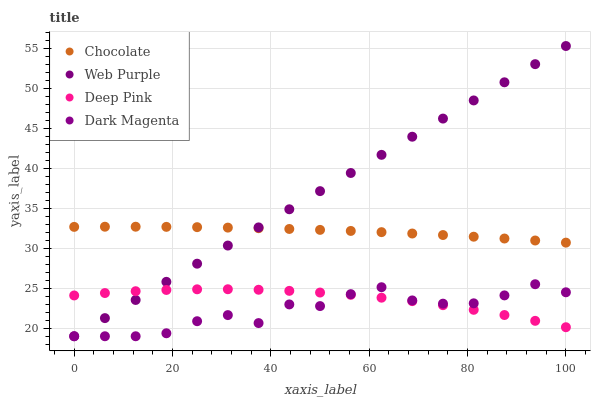Does Dark Magenta have the minimum area under the curve?
Answer yes or no. Yes. Does Web Purple have the maximum area under the curve?
Answer yes or no. Yes. Does Deep Pink have the minimum area under the curve?
Answer yes or no. No. Does Deep Pink have the maximum area under the curve?
Answer yes or no. No. Is Web Purple the smoothest?
Answer yes or no. Yes. Is Dark Magenta the roughest?
Answer yes or no. Yes. Is Deep Pink the smoothest?
Answer yes or no. No. Is Deep Pink the roughest?
Answer yes or no. No. Does Web Purple have the lowest value?
Answer yes or no. Yes. Does Deep Pink have the lowest value?
Answer yes or no. No. Does Web Purple have the highest value?
Answer yes or no. Yes. Does Dark Magenta have the highest value?
Answer yes or no. No. Is Deep Pink less than Chocolate?
Answer yes or no. Yes. Is Chocolate greater than Deep Pink?
Answer yes or no. Yes. Does Web Purple intersect Deep Pink?
Answer yes or no. Yes. Is Web Purple less than Deep Pink?
Answer yes or no. No. Is Web Purple greater than Deep Pink?
Answer yes or no. No. Does Deep Pink intersect Chocolate?
Answer yes or no. No. 